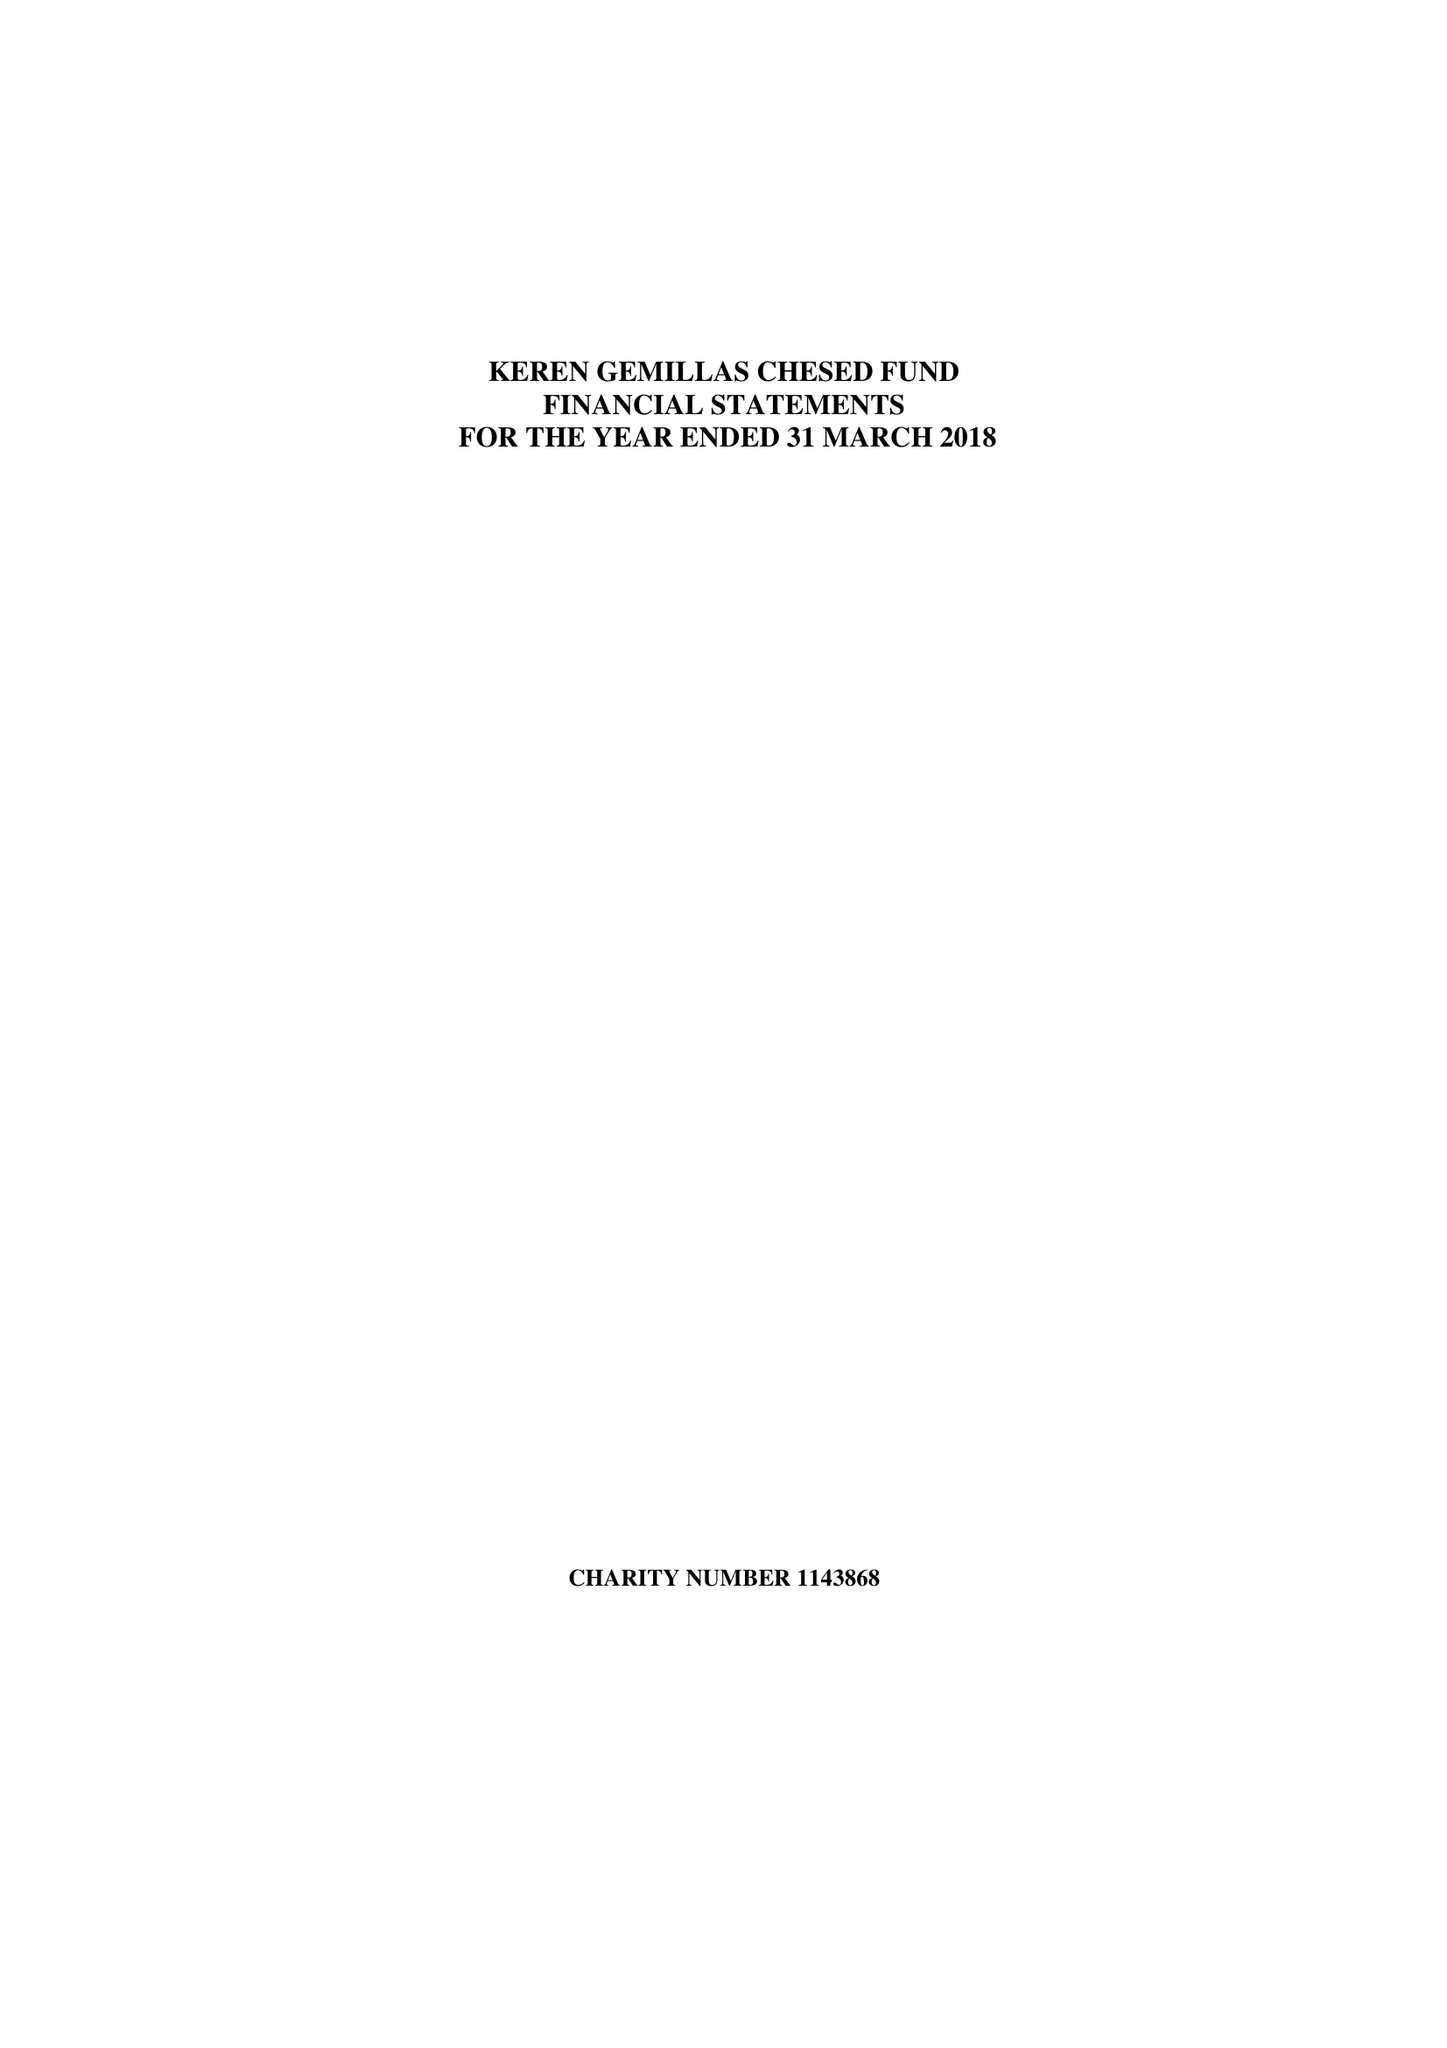What is the value for the income_annually_in_british_pounds?
Answer the question using a single word or phrase. 113787.00 